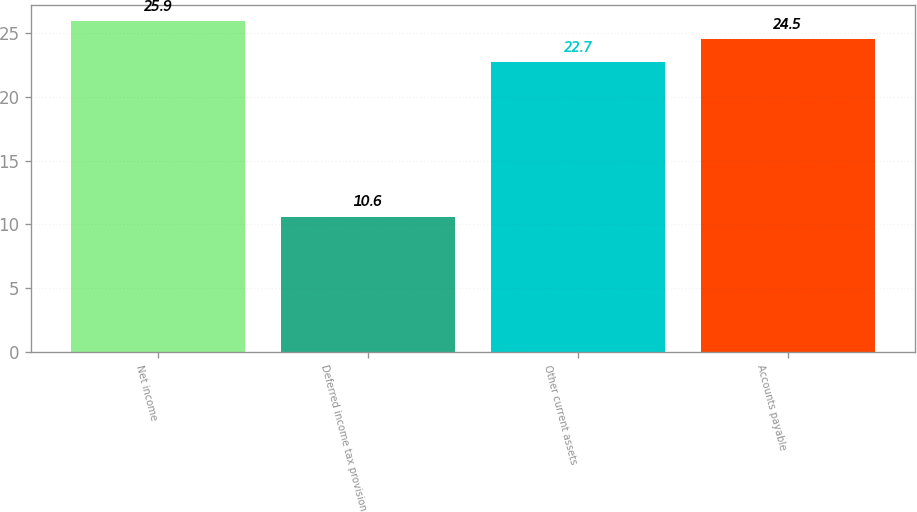Convert chart. <chart><loc_0><loc_0><loc_500><loc_500><bar_chart><fcel>Net income<fcel>Deferred income tax provision<fcel>Other current assets<fcel>Accounts payable<nl><fcel>25.9<fcel>10.6<fcel>22.7<fcel>24.5<nl></chart> 